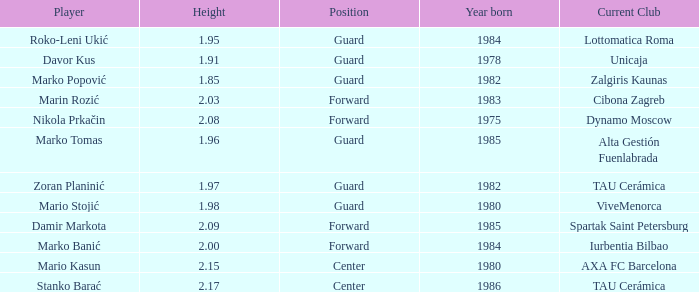What position does Mario Kasun play? Center. 